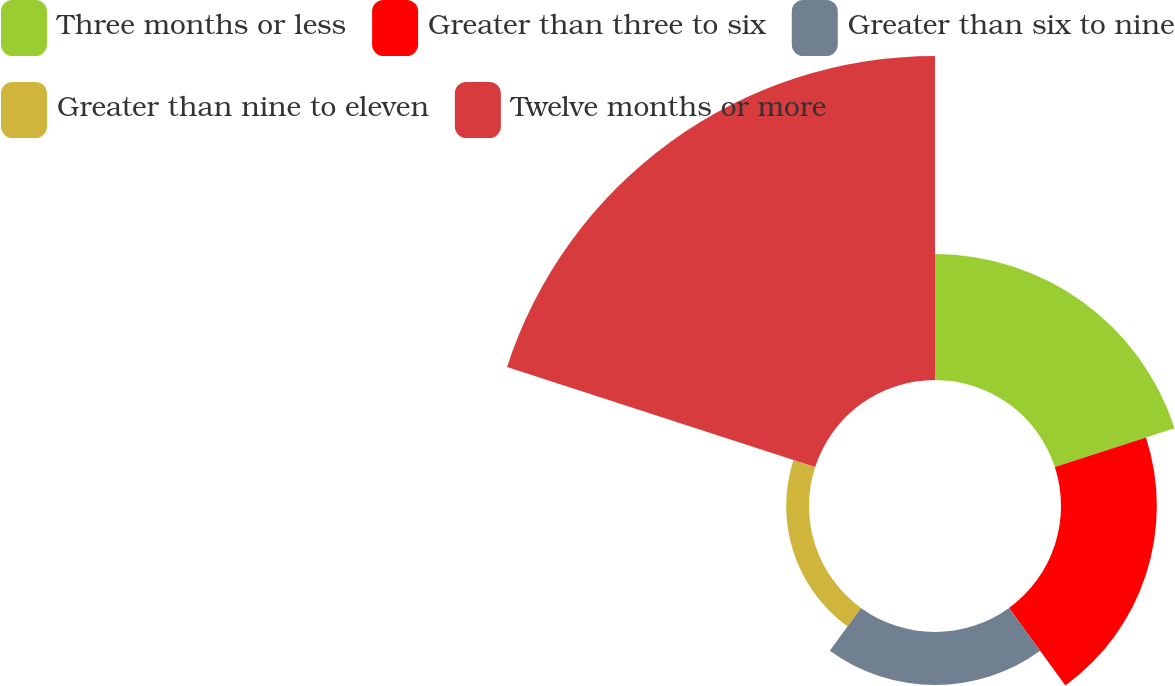Convert chart to OTSL. <chart><loc_0><loc_0><loc_500><loc_500><pie_chart><fcel>Three months or less<fcel>Greater than three to six<fcel>Greater than six to nine<fcel>Greater than nine to eleven<fcel>Twelve months or more<nl><fcel>20.26%<fcel>15.42%<fcel>8.52%<fcel>3.67%<fcel>52.13%<nl></chart> 